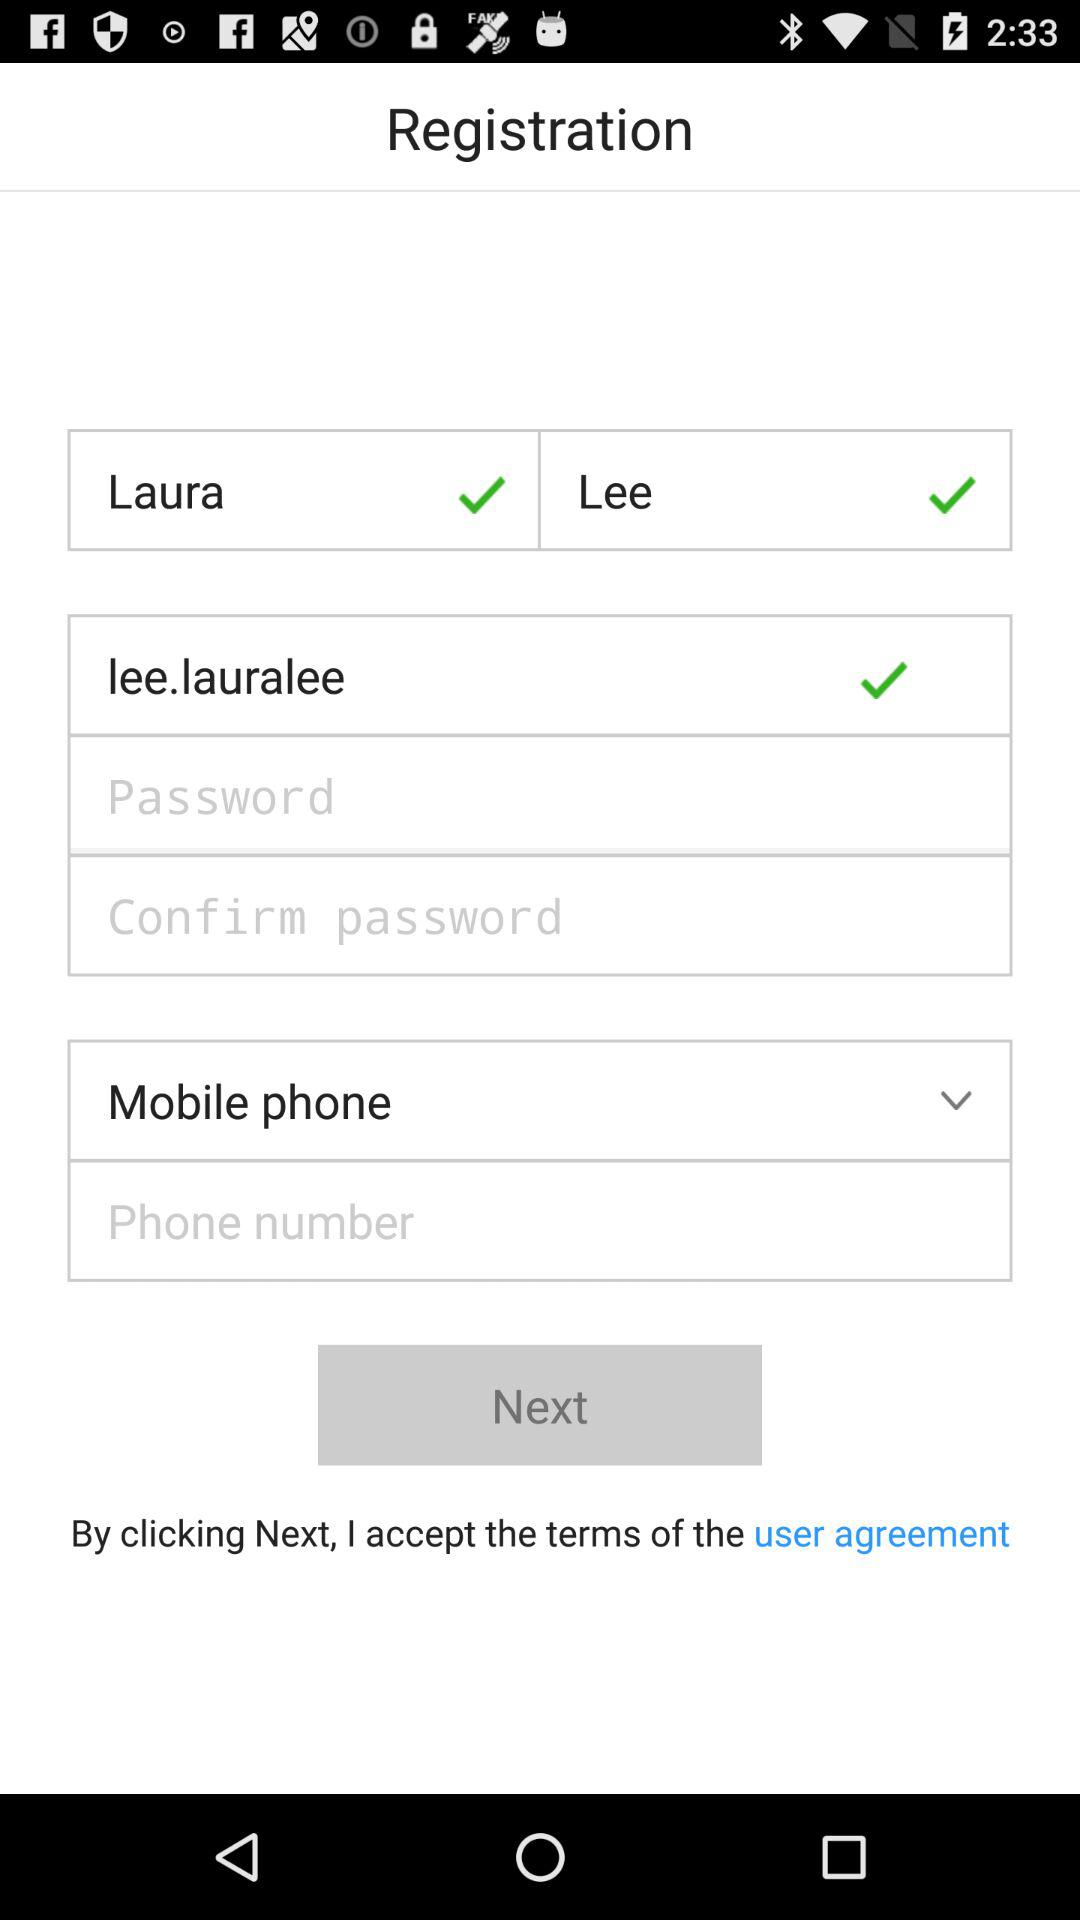How many characters are required in the password?
When the provided information is insufficient, respond with <no answer>. <no answer> 